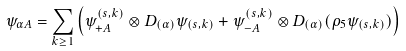Convert formula to latex. <formula><loc_0><loc_0><loc_500><loc_500>\psi _ { \alpha A } = \sum _ { k \geq 1 } \left ( \psi ^ { ( s , k ) } _ { + A } \otimes D _ { ( \alpha ) } \psi _ { ( s , k ) } + \psi ^ { ( s , k ) } _ { - A } \otimes D _ { ( \alpha ) } ( \rho _ { 5 } \psi _ { ( s , k ) } ) \right )</formula> 